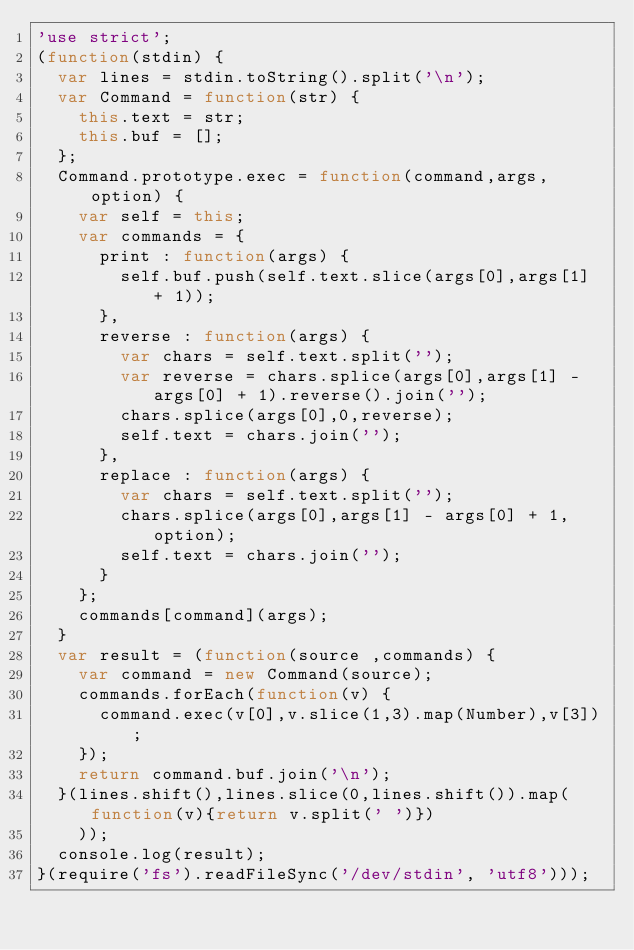<code> <loc_0><loc_0><loc_500><loc_500><_JavaScript_>'use strict';
(function(stdin) {
  var lines = stdin.toString().split('\n');
  var Command = function(str) {
    this.text = str;
    this.buf = [];
  };
  Command.prototype.exec = function(command,args,option) {
    var self = this;
    var commands = {
      print : function(args) {
        self.buf.push(self.text.slice(args[0],args[1] + 1));
      },
      reverse : function(args) {
        var chars = self.text.split('');
        var reverse = chars.splice(args[0],args[1] - args[0] + 1).reverse().join('');
        chars.splice(args[0],0,reverse);
        self.text = chars.join('');
      },
      replace : function(args) {
        var chars = self.text.split('');
        chars.splice(args[0],args[1] - args[0] + 1,option);
        self.text = chars.join('');
      }
    };
    commands[command](args);
  }
  var result = (function(source ,commands) {
    var command = new Command(source);
    commands.forEach(function(v) {
      command.exec(v[0],v.slice(1,3).map(Number),v[3]);
    });
    return command.buf.join('\n');
  }(lines.shift(),lines.slice(0,lines.shift()).map(function(v){return v.split(' ')})
    ));
  console.log(result);
}(require('fs').readFileSync('/dev/stdin', 'utf8')));</code> 